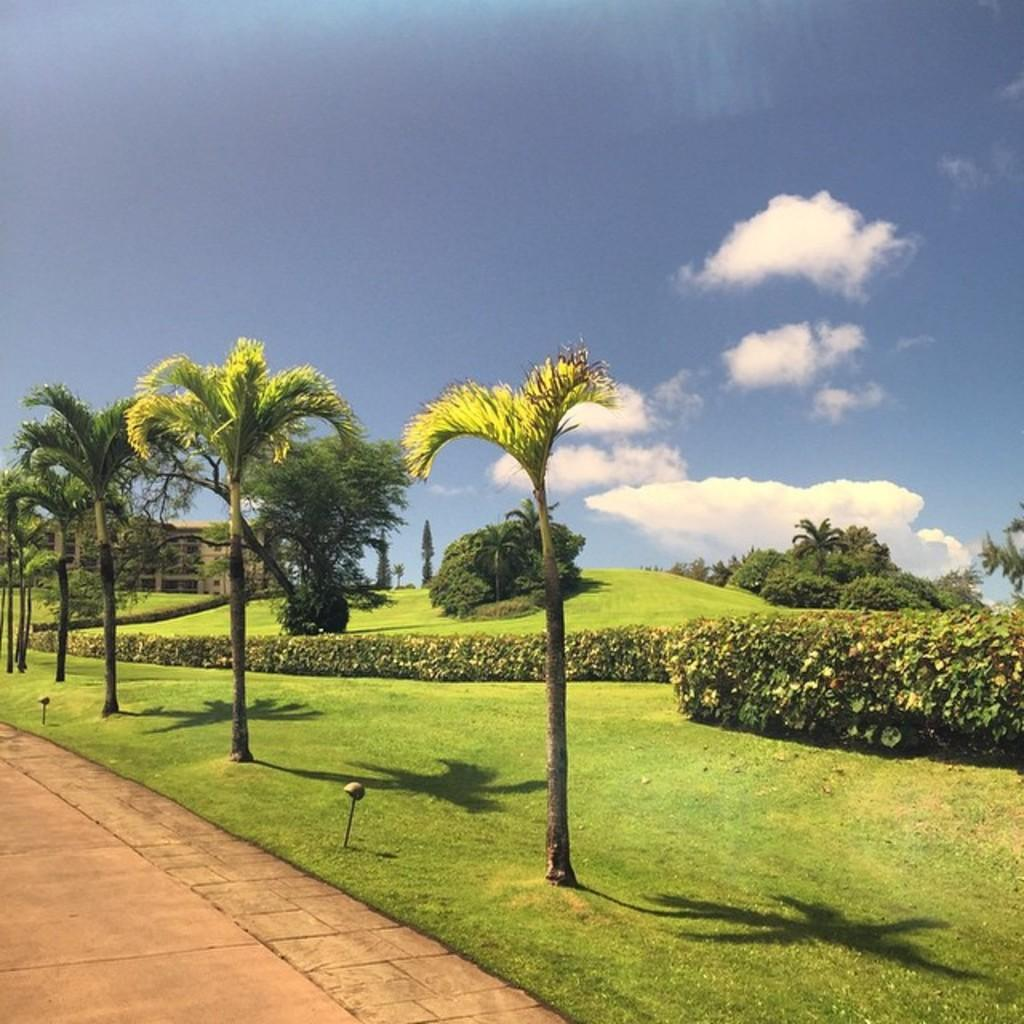What type of natural elements are present in the image? The image contains trees and plants. What is the color of the grass at the bottom of the image? There is green grass at the bottom of the image. Where is the road located in the image? The road is on the left side of the image. What can be seen in the sky at the top of the image? There are clouds in the sky at the top of the image. What type of lipstick is the brother wearing in the image? There is no brother or lipstick present in the image; it features trees, plants, grass, a road, and clouds. 